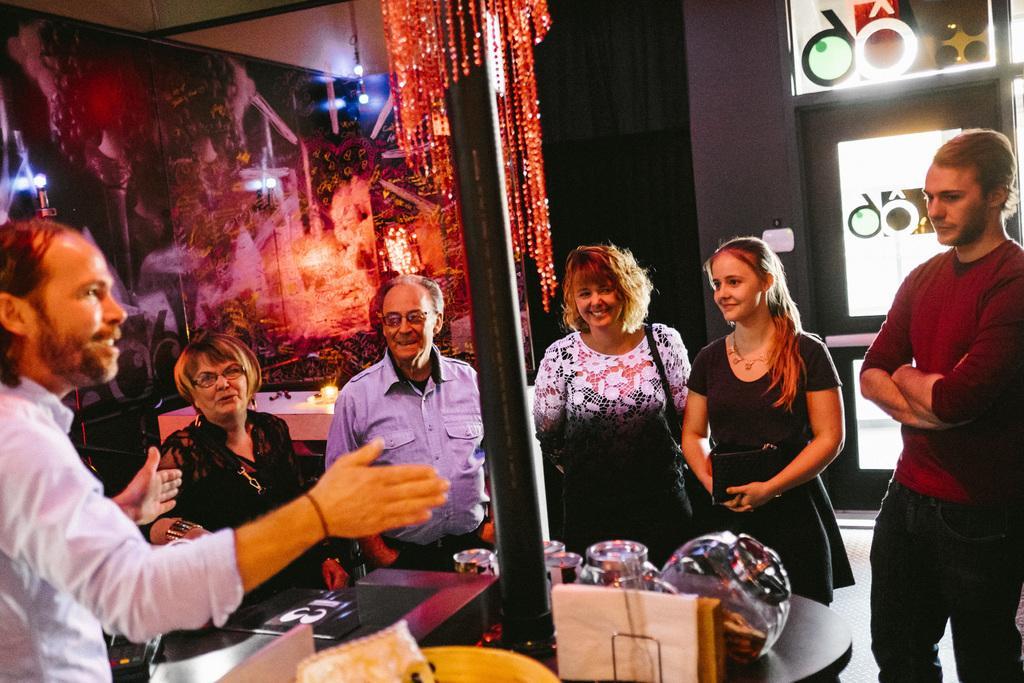Please provide a concise description of this image. In this image there are people having a smile on their faces. In front of them there is a table. On top of it there are a few objects. There is a pole. Behind them there is another table. On top of it there are some objects. Behind the table there is a poster on the wall. On the right side of the image there are glass windows with designs on it. 